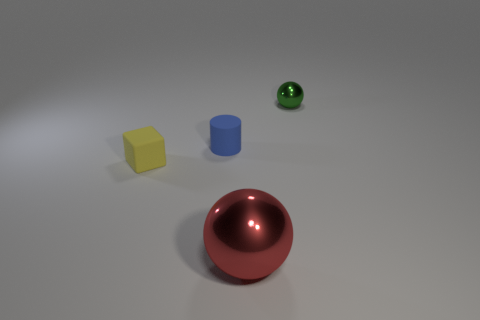Add 4 big gray cylinders. How many objects exist? 8 Subtract 0 blue blocks. How many objects are left? 4 Subtract all cylinders. How many objects are left? 3 Subtract all gray blocks. Subtract all green balls. How many blocks are left? 1 Subtract all yellow blocks. Subtract all big red objects. How many objects are left? 2 Add 2 blue matte objects. How many blue matte objects are left? 3 Add 2 big metal objects. How many big metal objects exist? 3 